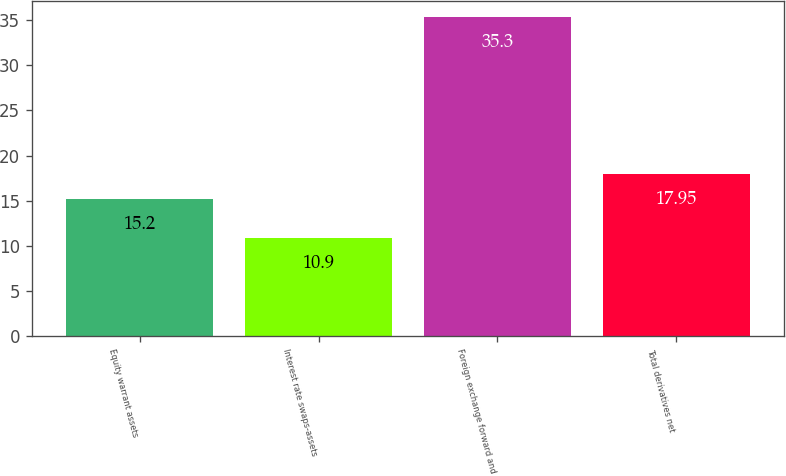Convert chart. <chart><loc_0><loc_0><loc_500><loc_500><bar_chart><fcel>Equity warrant assets<fcel>Interest rate swaps-assets<fcel>Foreign exchange forward and<fcel>Total derivatives net<nl><fcel>15.2<fcel>10.9<fcel>35.3<fcel>17.95<nl></chart> 